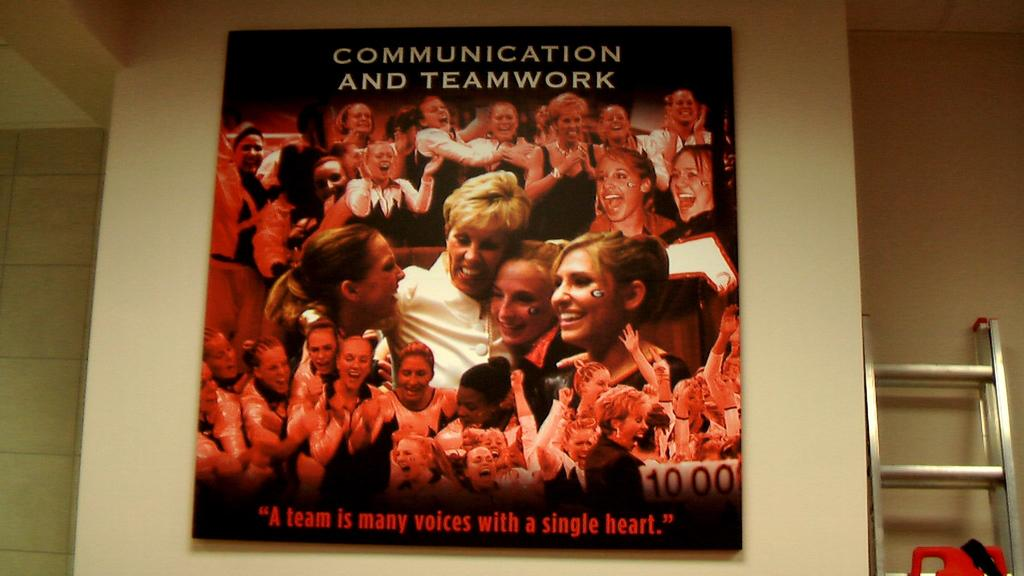<image>
Create a compact narrative representing the image presented. A large group of people smile in a poster for communication and teamwork. 